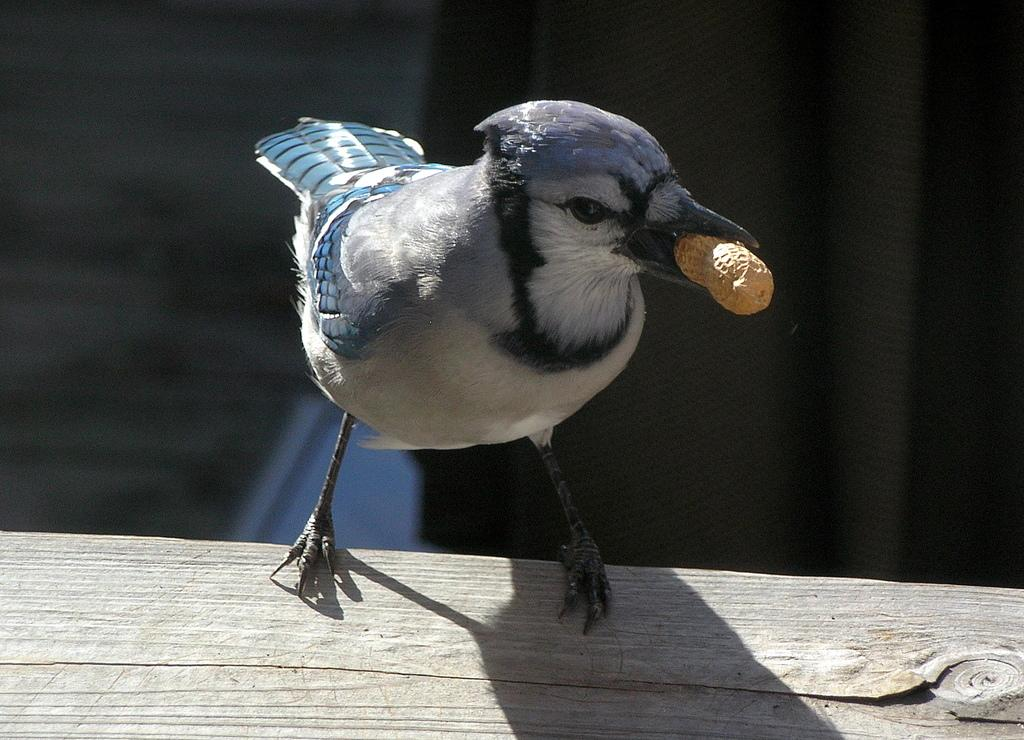What type of animal can be seen in the image? There is a bird in the image. Where is the bird located? The bird is on a wooden object. What is the bird holding in the image? The bird is holding a peanut. Can you describe the background of the image? The background of the image is blurred. What type of quartz can be seen in the image? There is no quartz present in the image. What channel is the bird watching in the image? There is no television or channel present in the image. 